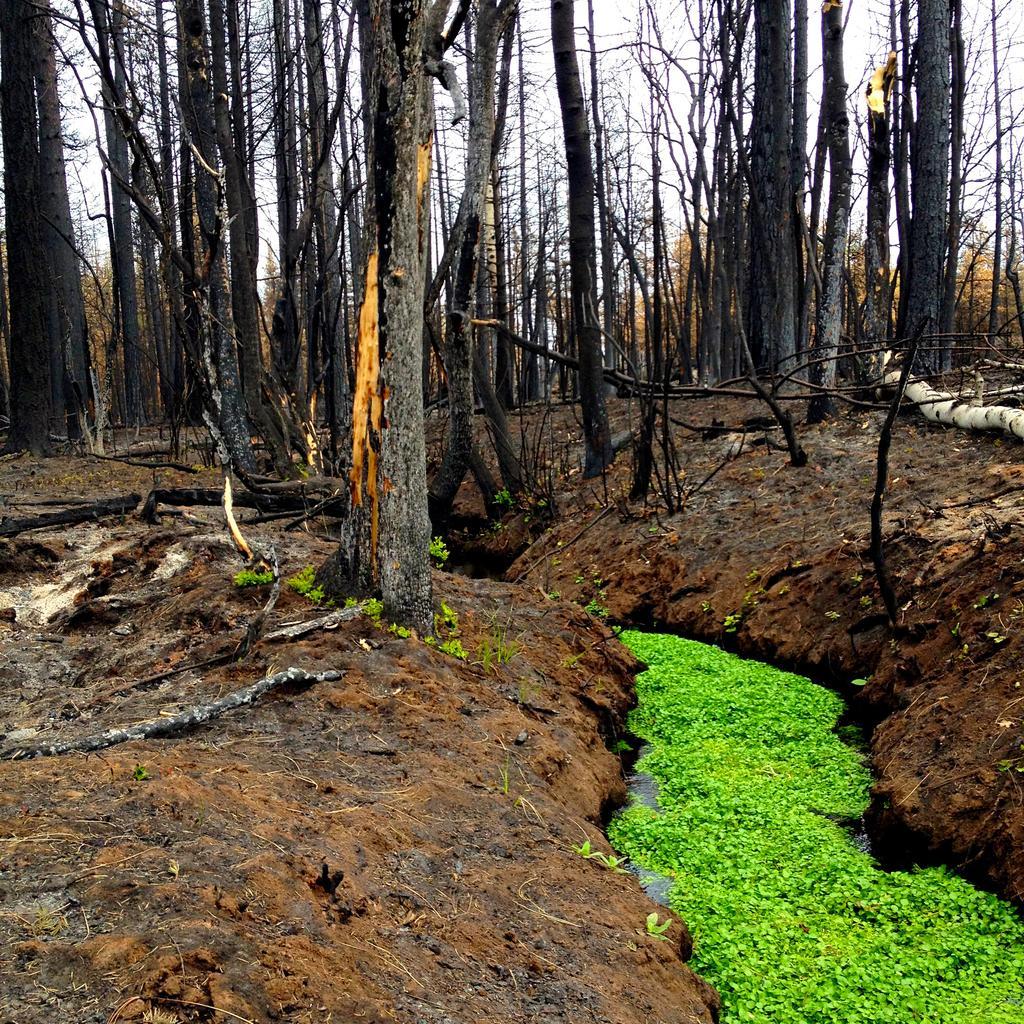Could you give a brief overview of what you see in this image? In this picture I can observe some trees. These trees are completely dried. In the background there is sky. 